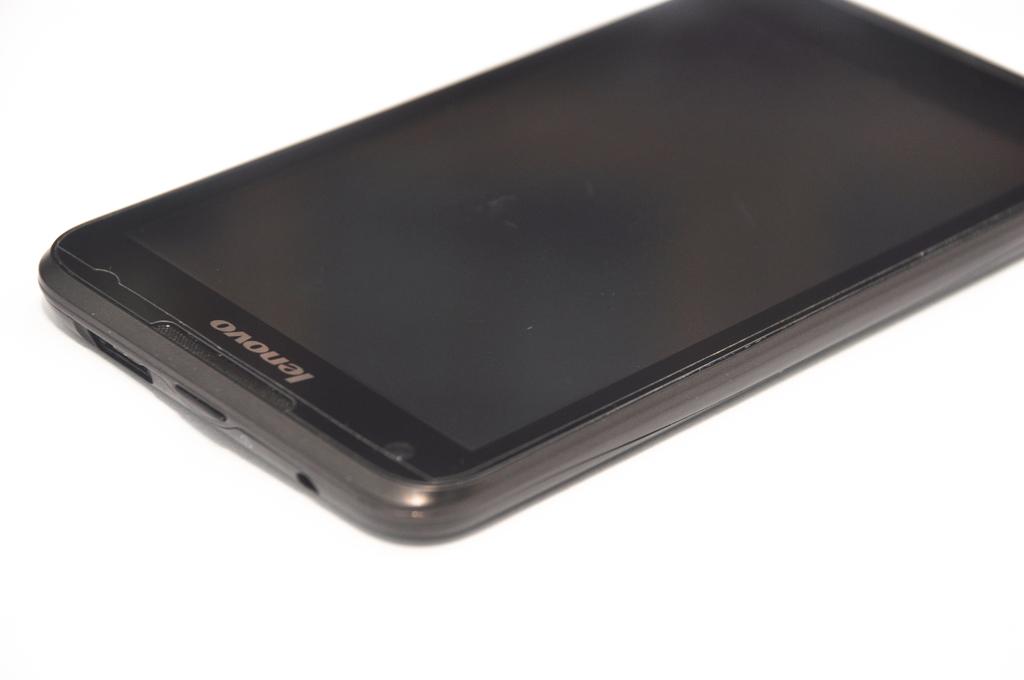Is this a creative agency?
Your answer should be compact. Unanswerable. 